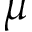Convert formula to latex. <formula><loc_0><loc_0><loc_500><loc_500>\mu</formula> 